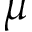Convert formula to latex. <formula><loc_0><loc_0><loc_500><loc_500>\mu</formula> 